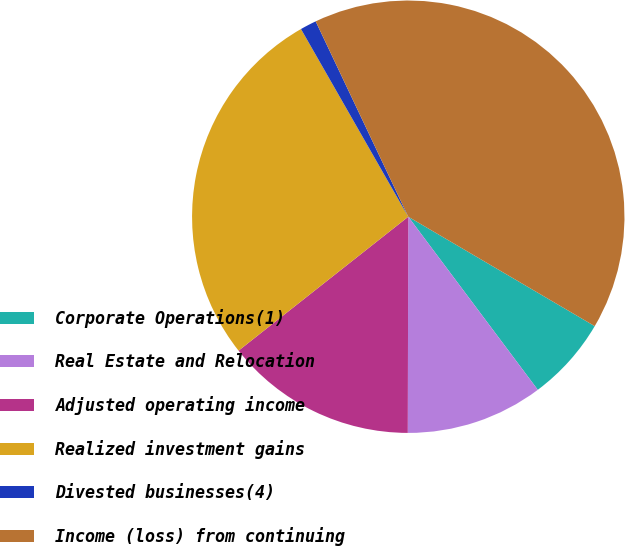Convert chart. <chart><loc_0><loc_0><loc_500><loc_500><pie_chart><fcel>Corporate Operations(1)<fcel>Real Estate and Relocation<fcel>Adjusted operating income<fcel>Realized investment gains<fcel>Divested businesses(4)<fcel>Income (loss) from continuing<nl><fcel>6.33%<fcel>10.26%<fcel>14.33%<fcel>27.37%<fcel>1.22%<fcel>40.49%<nl></chart> 